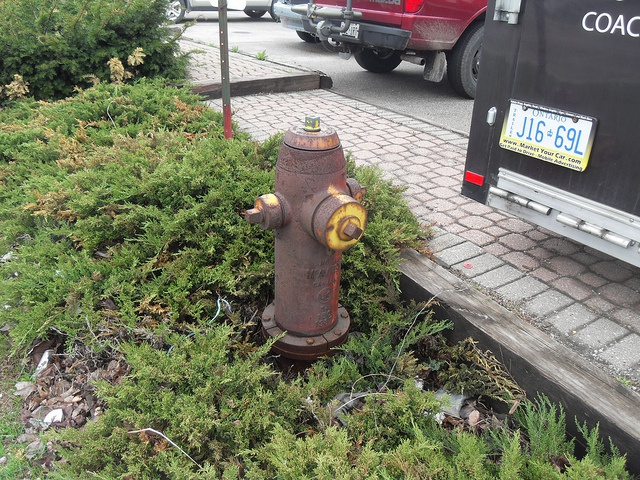Describe the objects in this image and their specific colors. I can see truck in olive, gray, lightgray, darkgray, and black tones, bus in olive, gray, lightgray, darkgray, and black tones, fire hydrant in olive, gray, black, and darkgray tones, truck in olive, gray, black, brown, and darkgray tones, and car in olive, gray, darkgray, lightgray, and black tones in this image. 